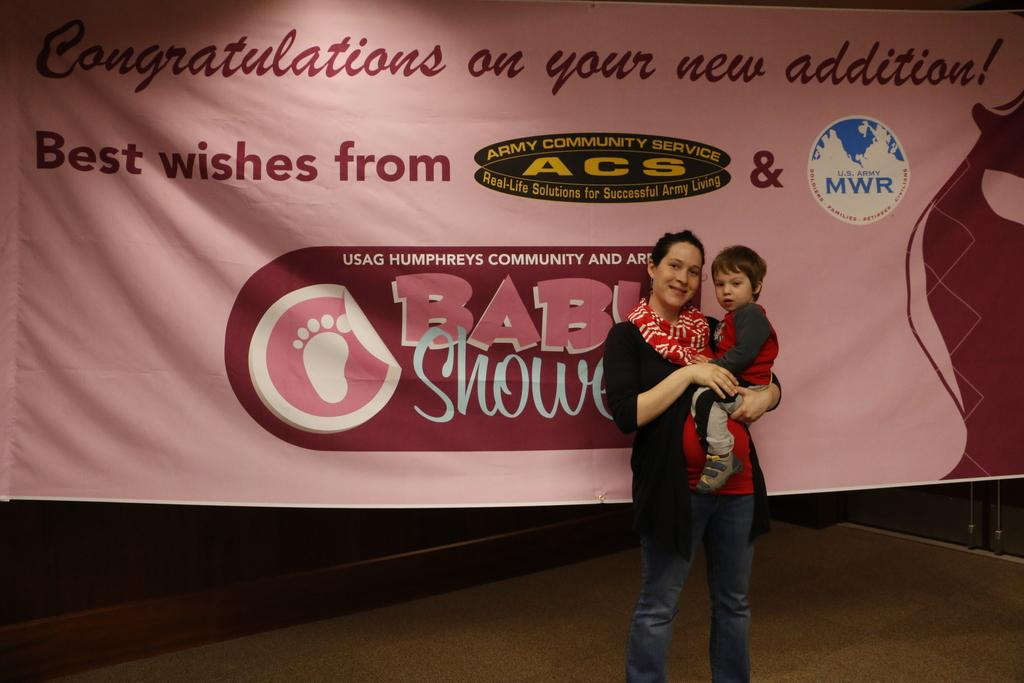Who is the main subject in the image? There is a woman in the image. What is the woman wearing? The woman is wearing a black jacket. What is the woman doing in the image? The woman is holding a kid. What can be seen in the background of the image? There is a banner in the background of the image. What is visible at the bottom of the image? There is a floor visible at the bottom of the image. Where is the door located in the image? There is a door on the right side of the image. What type of car is the woman suggesting to the kid in the image? There is no car present in the image, and the woman is not making any suggestions to the kid. 